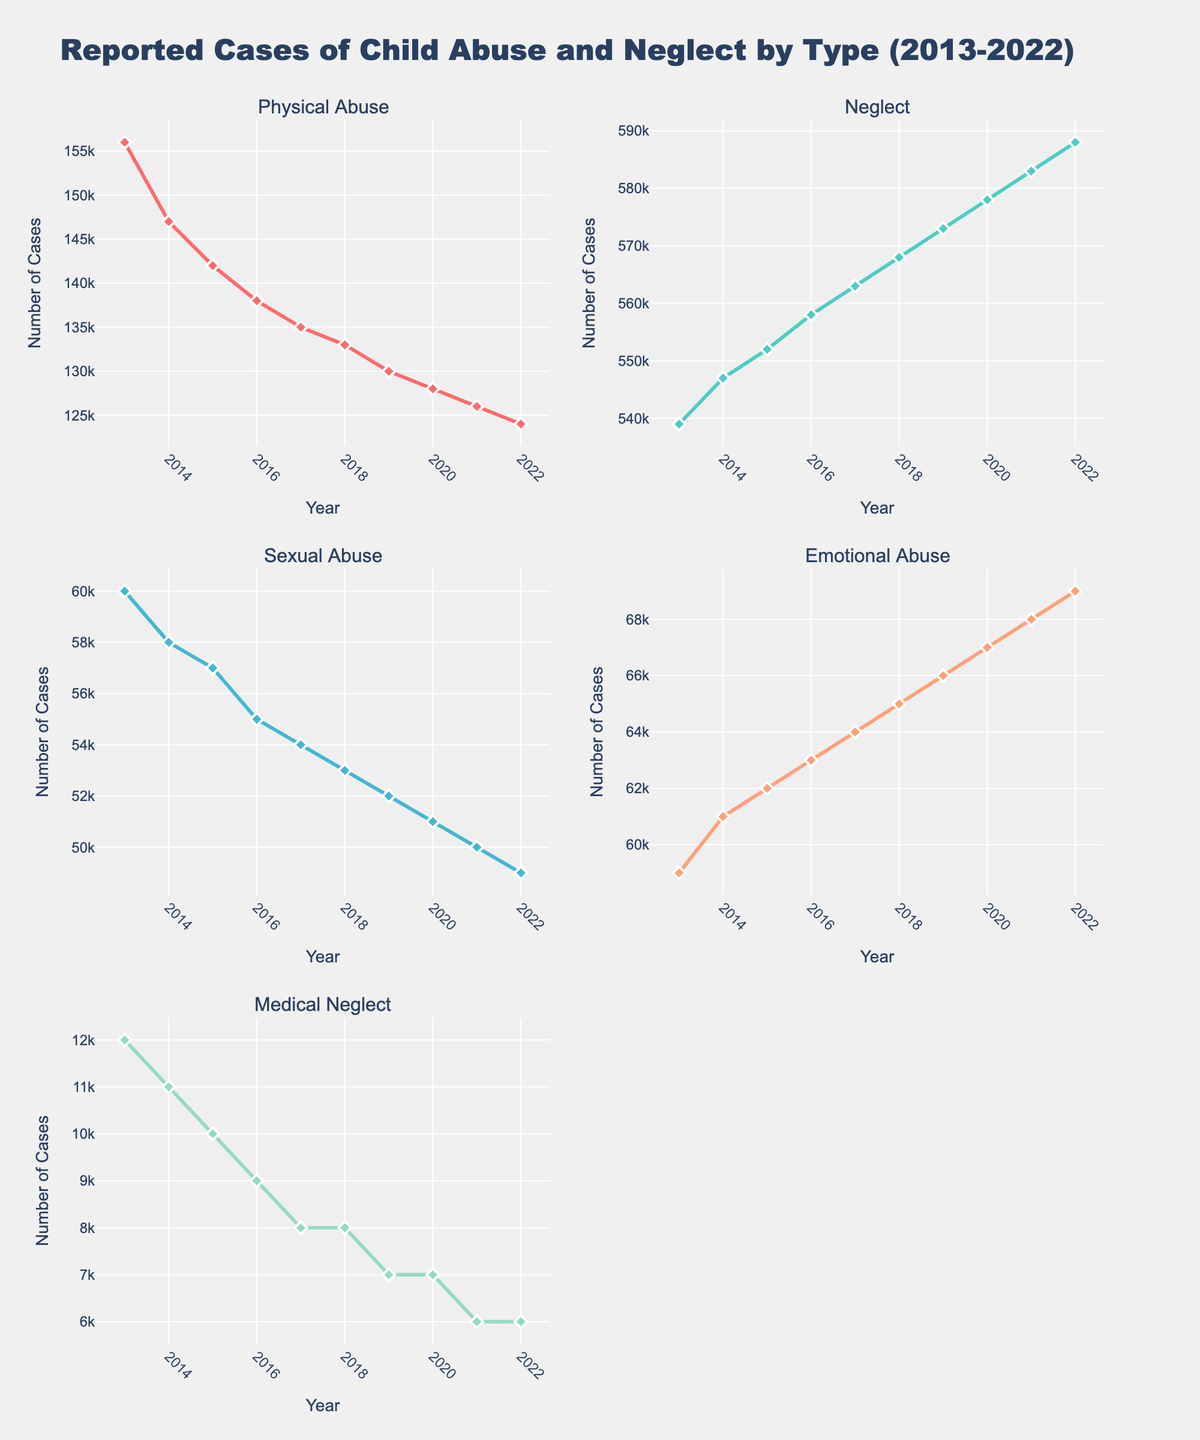What is the overall trend for reported cases of Physical Abuse from 2013 to 2022? The line for Physical Abuse cases consistently trends downward from 156,000 cases in 2013 to 124,000 cases in 2022. This indicates a decline.
Answer: Downward trend Which type of abuse had the highest number of reported cases in 2022? By looking at the height of the lines, Neglect had the highest number of reported cases in 2022 with 588,000 cases.
Answer: Neglect How have the reported cases of Medical Neglect changed over the years? Observing the trend line for Medical Neglect, it shows a consistent decline from 12,000 cases in 2013 to 6,000 cases in 2022.
Answer: Decline By how much did the cases of Emotional Abuse increase from 2013 to 2022? The cases of Emotional Abuse increased from 59,000 in 2013 to 69,000 in 2022. The difference is 69,000 - 59,000 = 10,000.
Answer: 10,000 Which type of abuse had the least variation in reported cases over the decade? Observing the lines for each type of abuse, Medical Neglect shows very little variation, hovering around 6,000 to 12,000 cases across the years.
Answer: Medical Neglect Compare the reported cases of Sexual Abuse and Emotional Abuse in 2019. Which one was higher and by how much? For 2019, Sexual Abuse cases were 52,000 and Emotional Abuse cases were 66,000. Emotional Abuse was higher by 66,000 - 52,000 = 14,000 cases.
Answer: Emotional Abuse by 14,000 What was the percentage decrease in Physical Abuse cases from 2013 to 2022? The decrease is from 156,000 cases in 2013 to 124,000 cases in 2022. The percentage decrease is ((156,000 - 124,000) / 156,000) * 100 = 20.51%.
Answer: 20.51% Which type of abuse shows an increasing trend over the decade? By examining the trend lines, Emotional Abuse cases consistently increase from 59,000 in 2013 to 69,000 in 2022.
Answer: Emotional Abuse 